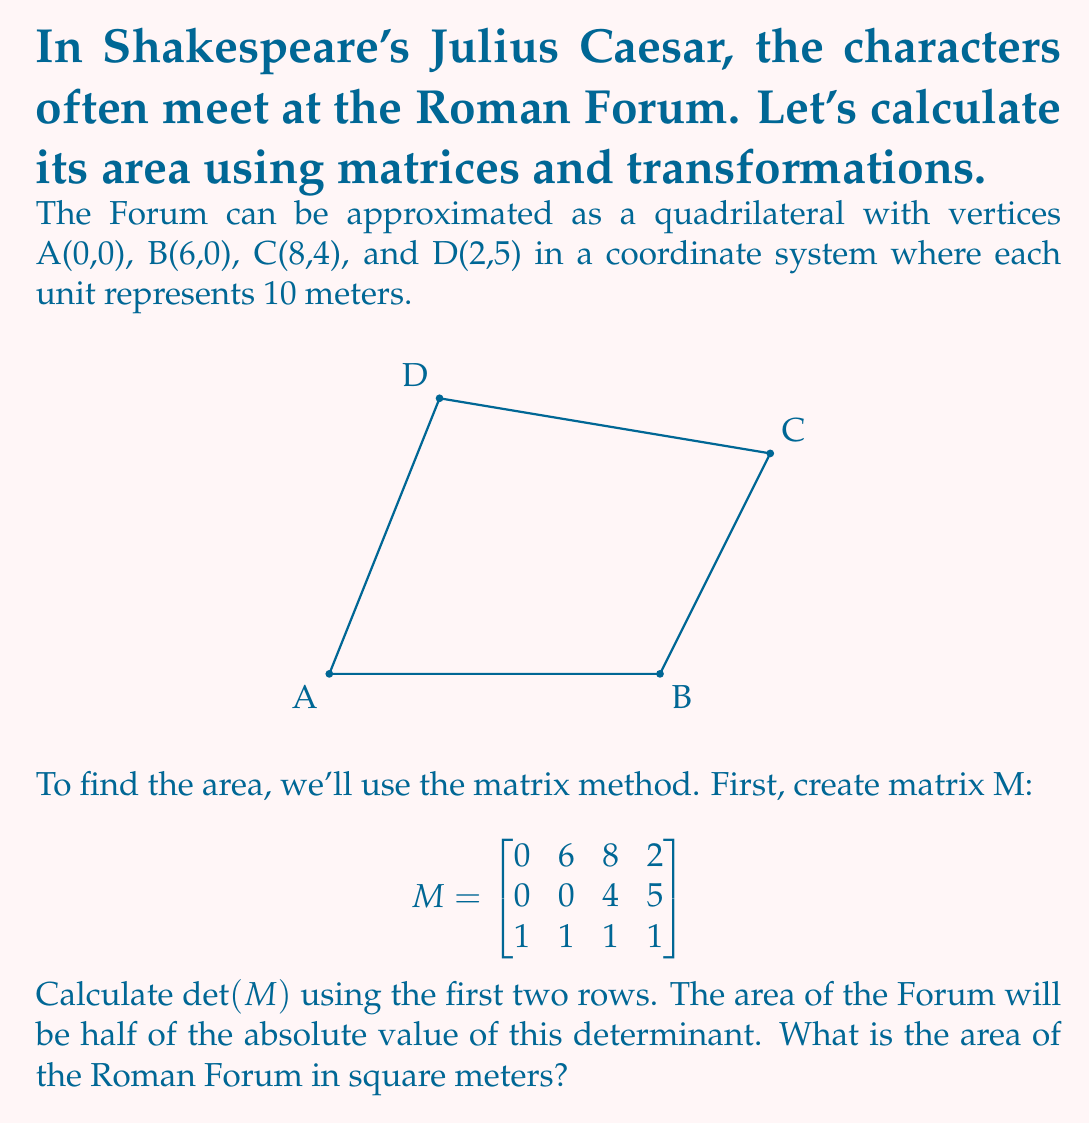Teach me how to tackle this problem. Let's solve this step-by-step:

1) We have the matrix M:
   $$M = \begin{bmatrix}
   0 & 6 & 8 & 2 \\
   0 & 0 & 4 & 5 \\
   1 & 1 & 1 & 1
   \end{bmatrix}$$

2) To calculate the determinant using the first two rows, we use the formula:
   $\det(M) = (x_1y_2 - x_2y_1) + (x_2y_3 - x_3y_2) + (x_3y_4 - x_4y_3) + (x_4y_1 - x_1y_4)$

   Where $(x_1,y_1)$, $(x_2,y_2)$, $(x_3,y_3)$, and $(x_4,y_4)$ are the coordinates of A, B, C, and D respectively.

3) Let's substitute the values:
   $\det(M) = (0 \cdot 0 - 6 \cdot 0) + (6 \cdot 4 - 8 \cdot 0) + (8 \cdot 5 - 2 \cdot 4) + (2 \cdot 0 - 0 \cdot 5)$

4) Simplify:
   $\det(M) = 0 + 24 + 32 + 0 = 56$

5) The area of the quadrilateral is half the absolute value of this determinant:
   Area $= \frac{1}{2} |\det(M)| = \frac{1}{2} \cdot 56 = 28$

6) Remember that each unit represents 10 meters, so we need to multiply by $10^2 = 100$:
   Area $= 28 \cdot 100 = 2800$ square meters

Therefore, the area of the Roman Forum is 2800 square meters.
Answer: 2800 square meters 